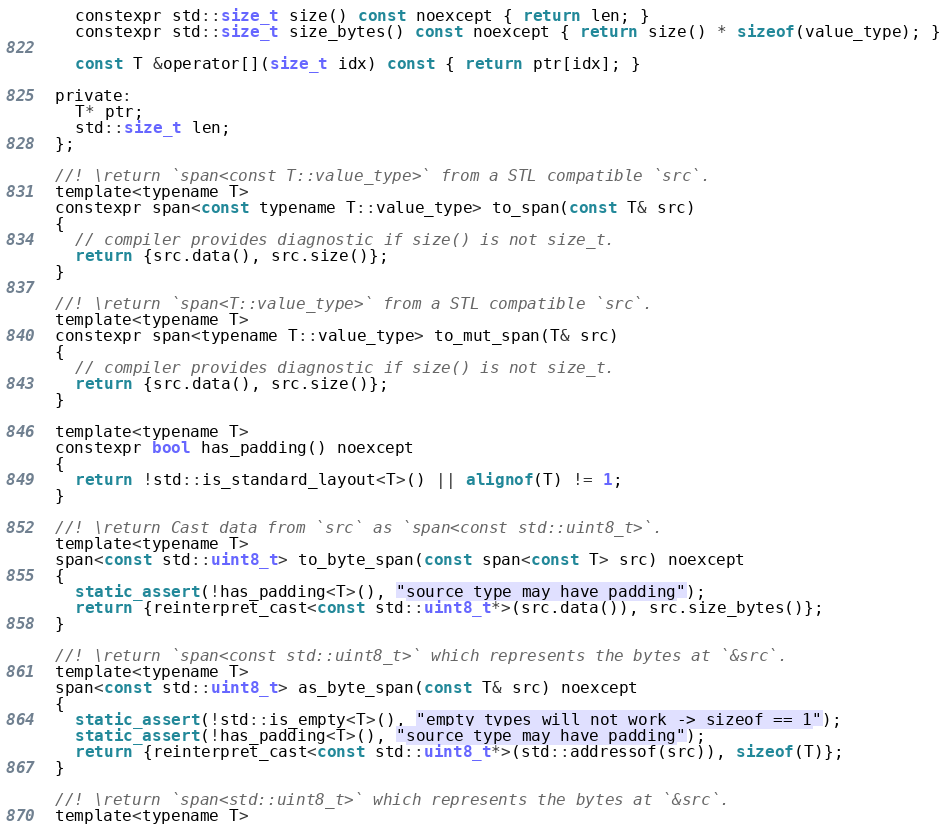<code> <loc_0><loc_0><loc_500><loc_500><_C_>    constexpr std::size_t size() const noexcept { return len; }
    constexpr std::size_t size_bytes() const noexcept { return size() * sizeof(value_type); }

    const T &operator[](size_t idx) const { return ptr[idx]; }

  private:
    T* ptr;
    std::size_t len;
  };

  //! \return `span<const T::value_type>` from a STL compatible `src`.
  template<typename T>
  constexpr span<const typename T::value_type> to_span(const T& src)
  {
    // compiler provides diagnostic if size() is not size_t.
    return {src.data(), src.size()};
  }

  //! \return `span<T::value_type>` from a STL compatible `src`.
  template<typename T>
  constexpr span<typename T::value_type> to_mut_span(T& src)
  {
    // compiler provides diagnostic if size() is not size_t.
    return {src.data(), src.size()};
  }

  template<typename T>
  constexpr bool has_padding() noexcept
  {
    return !std::is_standard_layout<T>() || alignof(T) != 1;
  }

  //! \return Cast data from `src` as `span<const std::uint8_t>`.
  template<typename T>
  span<const std::uint8_t> to_byte_span(const span<const T> src) noexcept
  {
    static_assert(!has_padding<T>(), "source type may have padding");
    return {reinterpret_cast<const std::uint8_t*>(src.data()), src.size_bytes()}; 
  }

  //! \return `span<const std::uint8_t>` which represents the bytes at `&src`.
  template<typename T>
  span<const std::uint8_t> as_byte_span(const T& src) noexcept
  {
    static_assert(!std::is_empty<T>(), "empty types will not work -> sizeof == 1");
    static_assert(!has_padding<T>(), "source type may have padding");
    return {reinterpret_cast<const std::uint8_t*>(std::addressof(src)), sizeof(T)};
  }

  //! \return `span<std::uint8_t>` which represents the bytes at `&src`.
  template<typename T></code> 